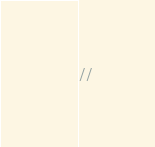<code> <loc_0><loc_0><loc_500><loc_500><_C_>//</code> 